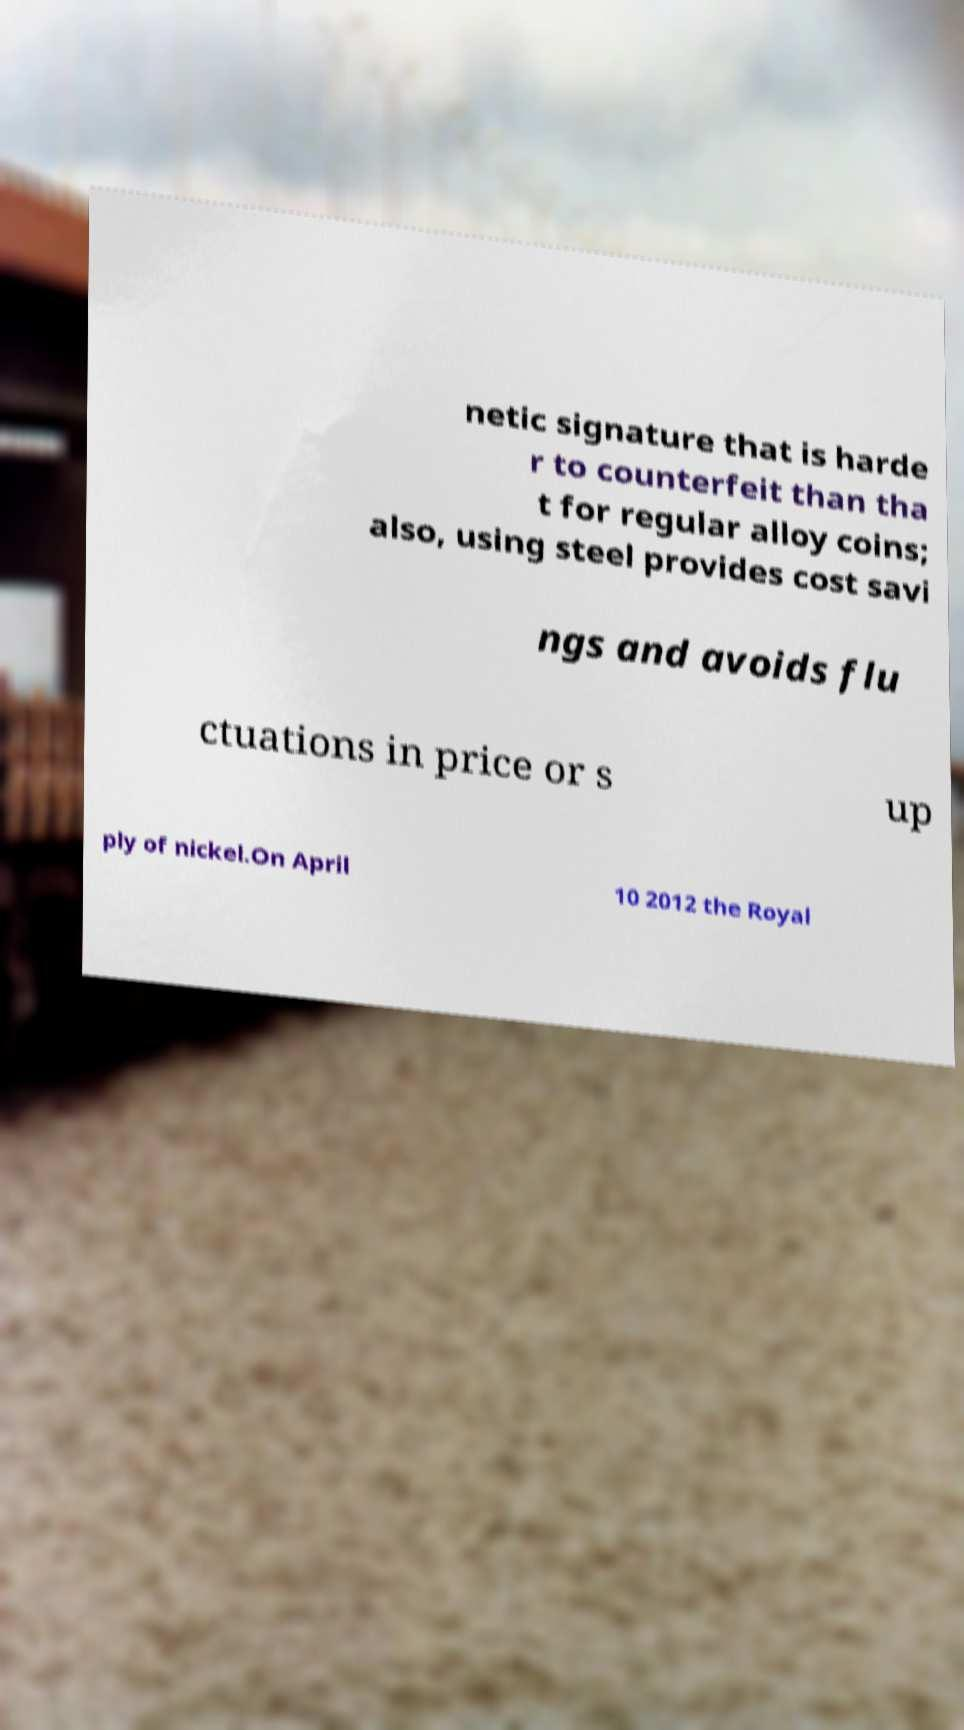For documentation purposes, I need the text within this image transcribed. Could you provide that? netic signature that is harde r to counterfeit than tha t for regular alloy coins; also, using steel provides cost savi ngs and avoids flu ctuations in price or s up ply of nickel.On April 10 2012 the Royal 